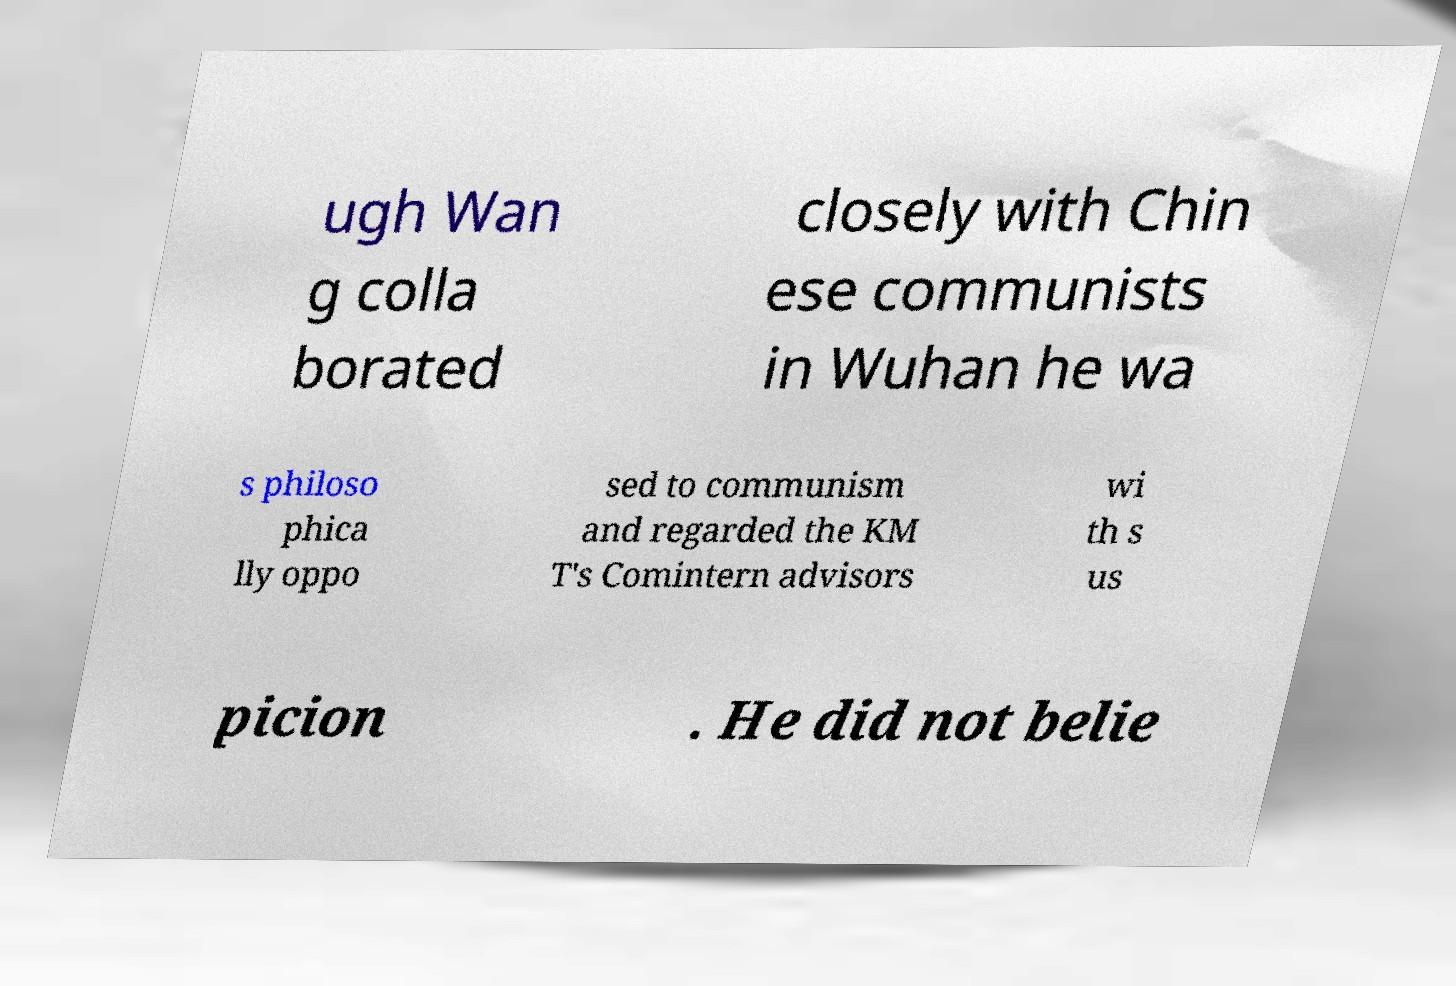For documentation purposes, I need the text within this image transcribed. Could you provide that? ugh Wan g colla borated closely with Chin ese communists in Wuhan he wa s philoso phica lly oppo sed to communism and regarded the KM T's Comintern advisors wi th s us picion . He did not belie 